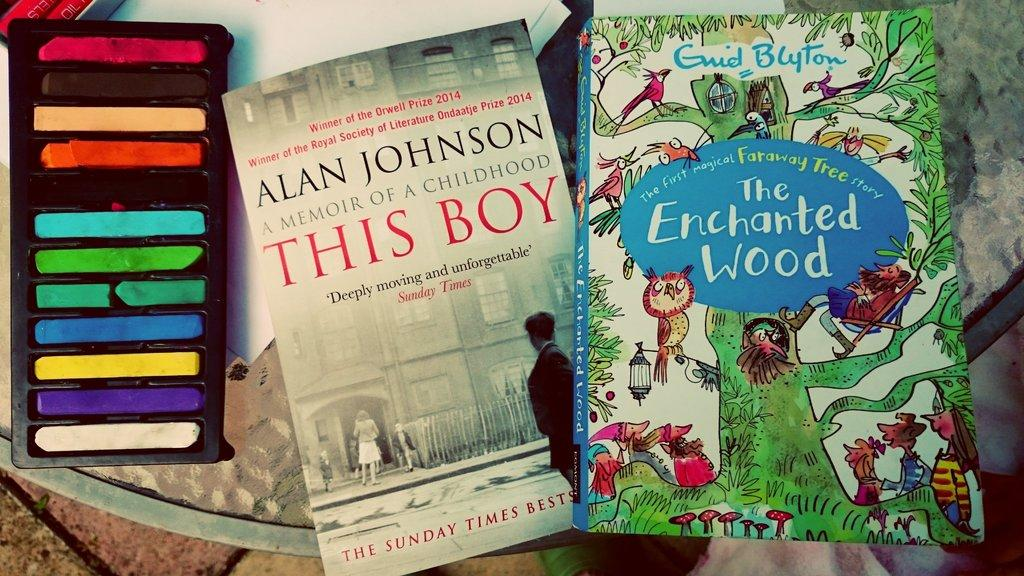What type of objects can be seen in the image? There are books in the image. What type of sea creatures can be seen swimming in the image? There are no sea creatures visible in the image; it only contains books. 